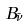Convert formula to latex. <formula><loc_0><loc_0><loc_500><loc_500>B _ { \tilde { \nu } }</formula> 